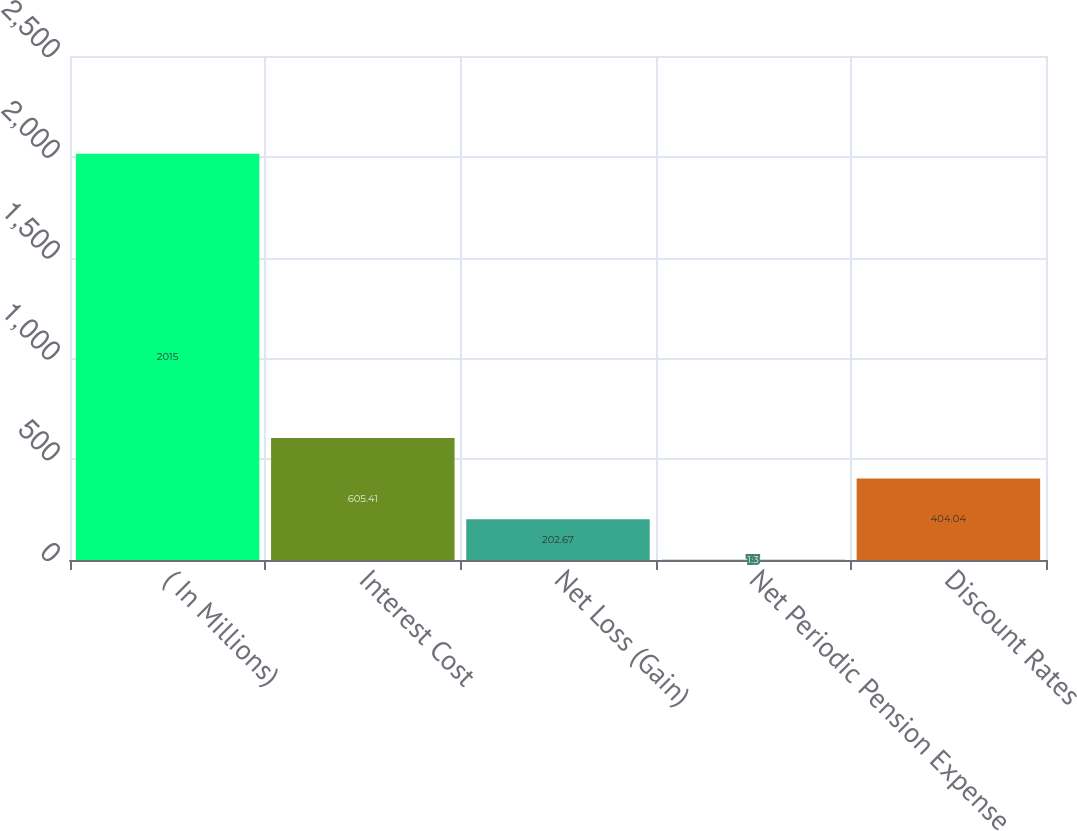Convert chart. <chart><loc_0><loc_0><loc_500><loc_500><bar_chart><fcel>( In Millions)<fcel>Interest Cost<fcel>Net Loss (Gain)<fcel>Net Periodic Pension Expense<fcel>Discount Rates<nl><fcel>2015<fcel>605.41<fcel>202.67<fcel>1.3<fcel>404.04<nl></chart> 